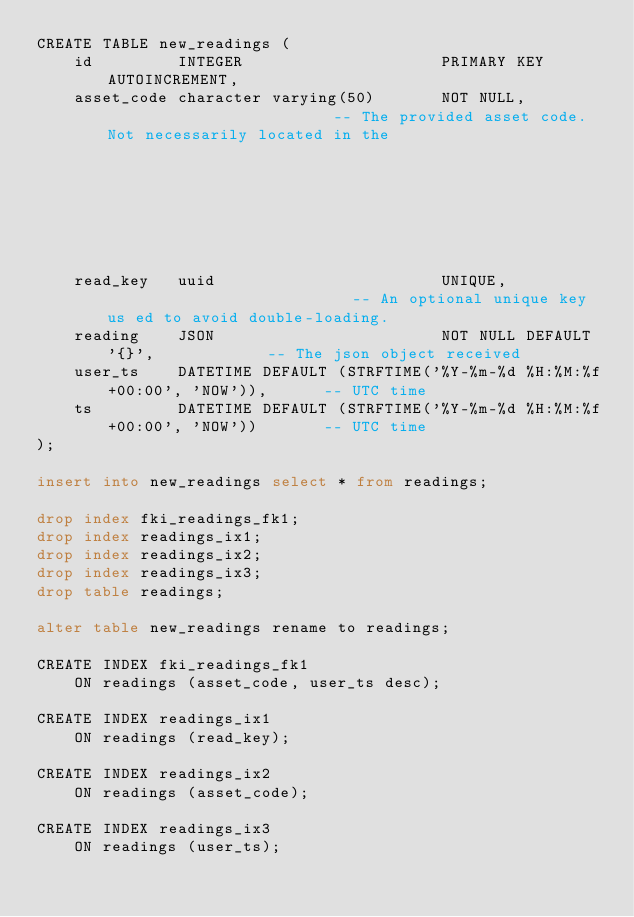Convert code to text. <code><loc_0><loc_0><loc_500><loc_500><_SQL_>CREATE TABLE new_readings (
    id         INTEGER                     PRIMARY KEY AUTOINCREMENT,
    asset_code character varying(50)       NOT NULL,                         -- The provided asset code.  Not necessarily located in the
                                                                             -- assets table.
    read_key   uuid                        UNIQUE,                           -- An optional unique key us ed to avoid double-loading.
    reading    JSON                        NOT NULL DEFAULT '{}',            -- The json object received
    user_ts    DATETIME DEFAULT (STRFTIME('%Y-%m-%d %H:%M:%f+00:00', 'NOW')),      -- UTC time
    ts         DATETIME DEFAULT (STRFTIME('%Y-%m-%d %H:%M:%f+00:00', 'NOW'))       -- UTC time
);

insert into new_readings select * from readings;

drop index fki_readings_fk1;
drop index readings_ix1;
drop index readings_ix2;
drop index readings_ix3;
drop table readings;

alter table new_readings rename to readings;

CREATE INDEX fki_readings_fk1
    ON readings (asset_code, user_ts desc);

CREATE INDEX readings_ix1
    ON readings (read_key);

CREATE INDEX readings_ix2
    ON readings (asset_code);

CREATE INDEX readings_ix3
    ON readings (user_ts);
</code> 